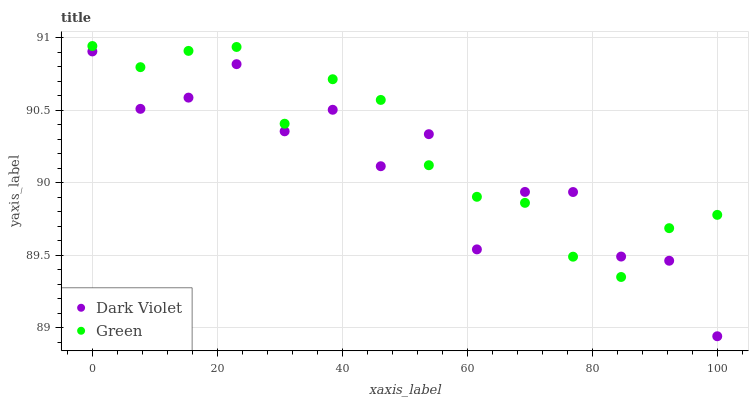Does Dark Violet have the minimum area under the curve?
Answer yes or no. Yes. Does Green have the maximum area under the curve?
Answer yes or no. Yes. Does Dark Violet have the maximum area under the curve?
Answer yes or no. No. Is Green the smoothest?
Answer yes or no. Yes. Is Dark Violet the roughest?
Answer yes or no. Yes. Is Dark Violet the smoothest?
Answer yes or no. No. Does Dark Violet have the lowest value?
Answer yes or no. Yes. Does Green have the highest value?
Answer yes or no. Yes. Does Dark Violet have the highest value?
Answer yes or no. No. Does Dark Violet intersect Green?
Answer yes or no. Yes. Is Dark Violet less than Green?
Answer yes or no. No. Is Dark Violet greater than Green?
Answer yes or no. No. 